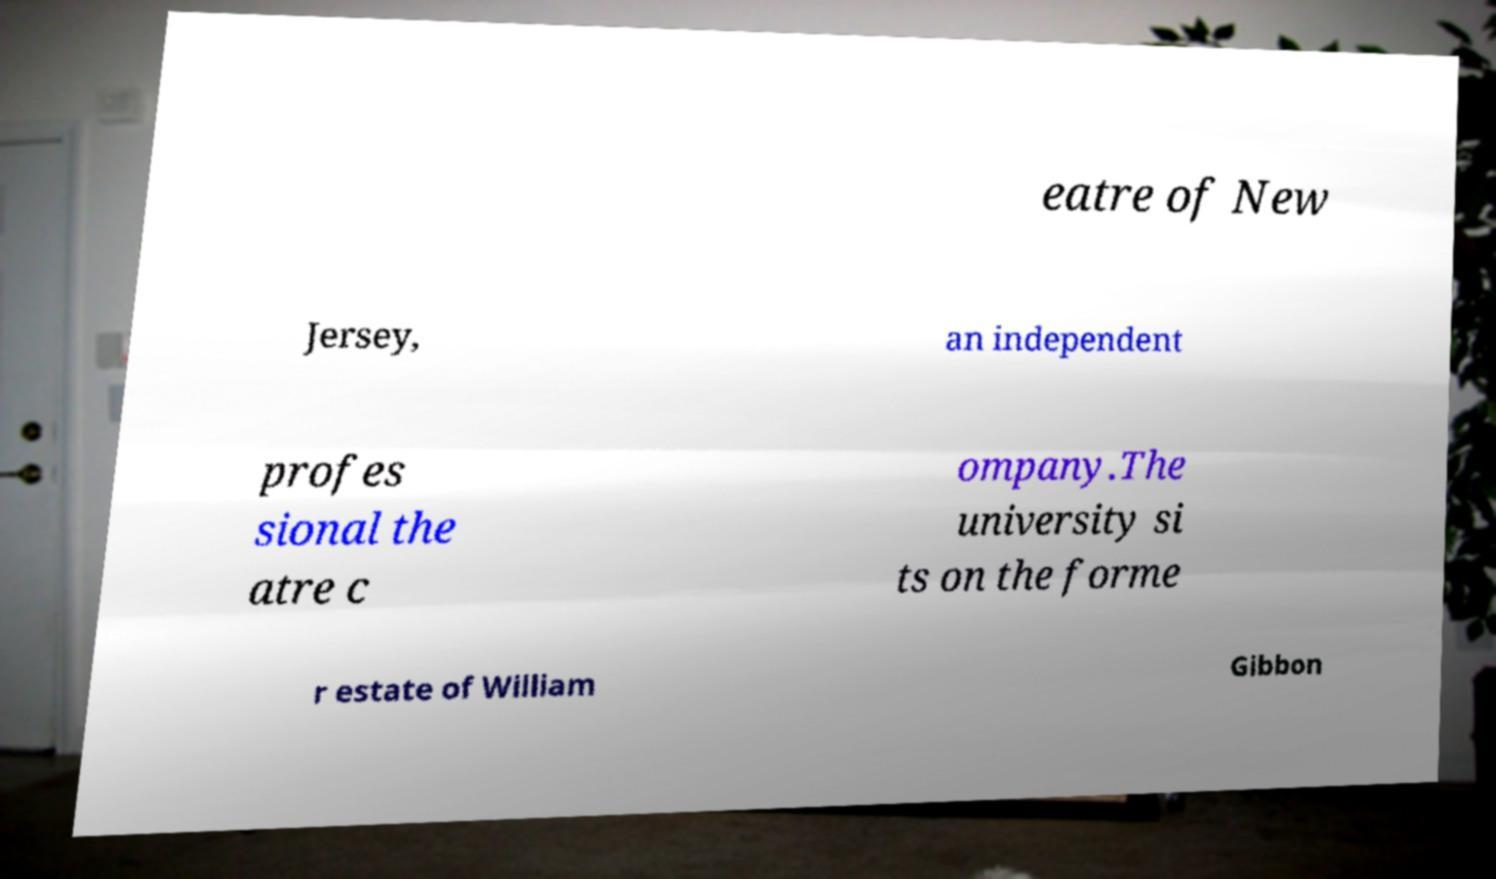I need the written content from this picture converted into text. Can you do that? eatre of New Jersey, an independent profes sional the atre c ompany.The university si ts on the forme r estate of William Gibbon 